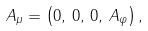Convert formula to latex. <formula><loc_0><loc_0><loc_500><loc_500>A _ { \mu } = \left ( 0 , \, 0 , \, 0 , \, A _ { \varphi } \right ) ,</formula> 